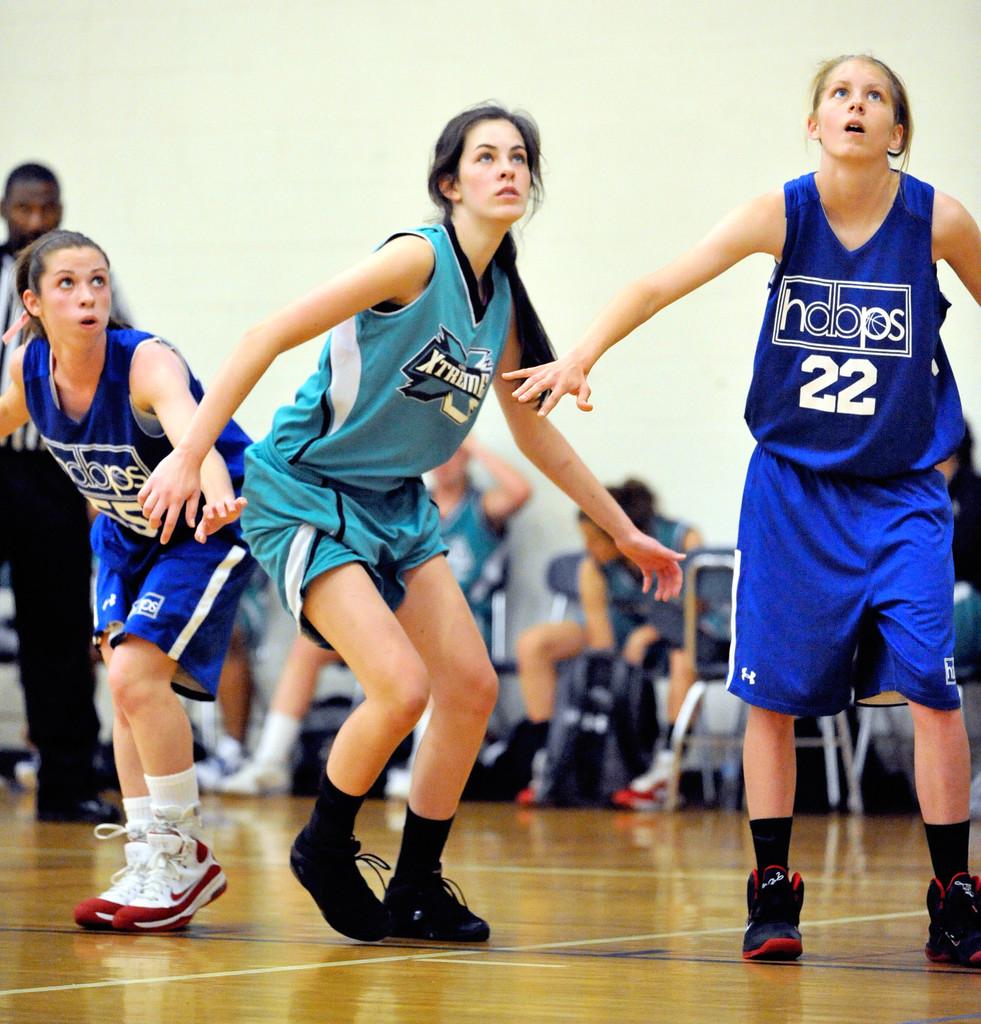What is the team name on the girls shirt to the very right?
Ensure brevity in your answer.  Hdbps. 